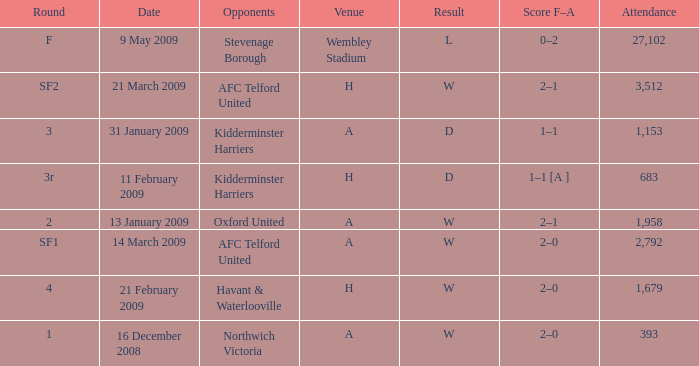Parse the full table. {'header': ['Round', 'Date', 'Opponents', 'Venue', 'Result', 'Score F–A', 'Attendance'], 'rows': [['F', '9 May 2009', 'Stevenage Borough', 'Wembley Stadium', 'L', '0–2', '27,102'], ['SF2', '21 March 2009', 'AFC Telford United', 'H', 'W', '2–1', '3,512'], ['3', '31 January 2009', 'Kidderminster Harriers', 'A', 'D', '1–1', '1,153'], ['3r', '11 February 2009', 'Kidderminster Harriers', 'H', 'D', '1–1 [A ]', '683'], ['2', '13 January 2009', 'Oxford United', 'A', 'W', '2–1', '1,958'], ['SF1', '14 March 2009', 'AFC Telford United', 'A', 'W', '2–0', '2,792'], ['4', '21 February 2009', 'Havant & Waterlooville', 'H', 'W', '2–0', '1,679'], ['1', '16 December 2008', 'Northwich Victoria', 'A', 'W', '2–0', '393']]} What is the round on 21 february 2009? 4.0. 